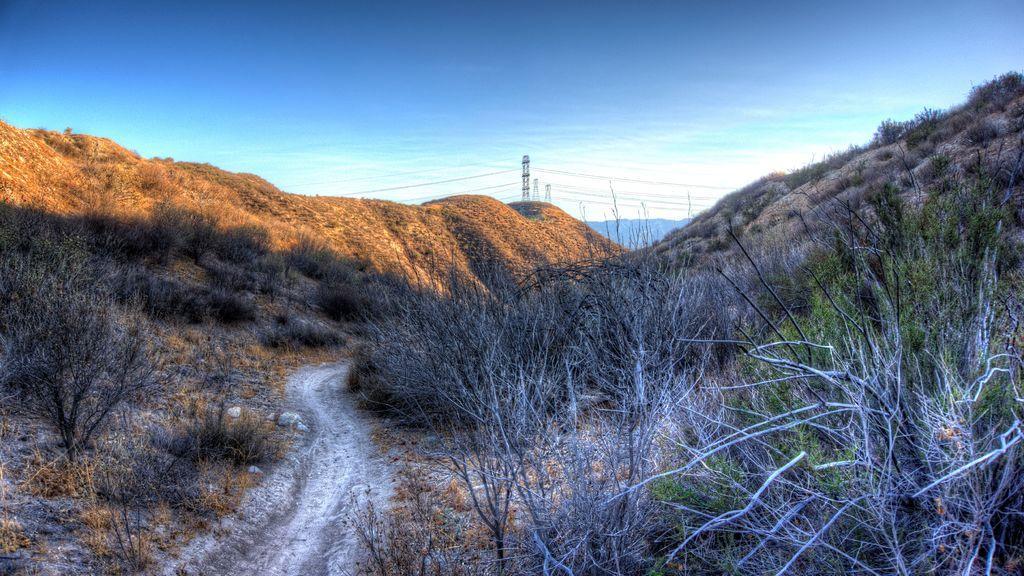Describe this image in one or two sentences. In this image in the front there are dry plants. In the background there are towers and there are mountains and the sky is cloudy. 